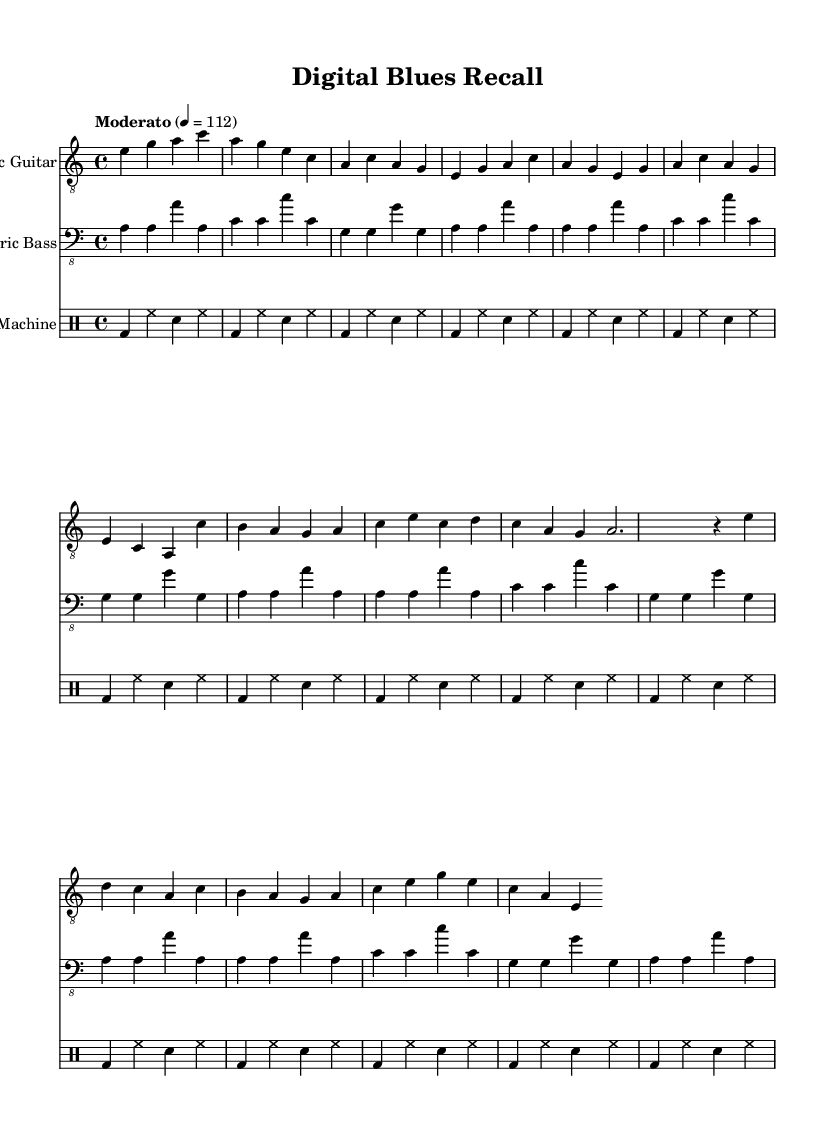What is the key signature of this music? The key signature indicated in the piece is A minor, which contains no sharps or flats. This can be identified from the initial part of the score where the key is specified.
Answer: A minor What is the time signature of this music? The time signature is 4/4, which means there are four beats in each measure. This is clearly labeled at the beginning of the score as part of the global settings.
Answer: 4/4 What is the indicated tempo of this music? The tempo is marked as "Moderato" with a metronome marking of 112 beats per minute. This specifies the speed at which the music should be played, as outlined in the global settings.
Answer: Moderato, 112 How many measures are in the verse section of the music? The verse section has four measures. This is determined by counting the measures listed in the electric guitar part; the verse consists of a sequence that includes four distinct measures.
Answer: 4 What style does this music represent? The style represented in the music is Electric Blues. This can be inferred from the structure, instrumentation, and elements present within the composition, reflecting characteristics of the Electric Blues genre.
Answer: Electric Blues How is the electric bass part structured in terms of repetition? The electric bass part is structured with a repeated pattern that unfolds four times. This is evident as the score shows a repeat symbol, indicating that this specific sequence of notes should be played four times consecutively.
Answer: 4 times What rhythmic element is consistently used in the drum machine part? The rhythmic element consistently used in the drum machine part is the bass drum (bd) and hi-hat (hh) pattern. This repeats throughout the measures, indicating a longstanding rhythmic foundation typical in this style.
Answer: bass drum and hi-hat 